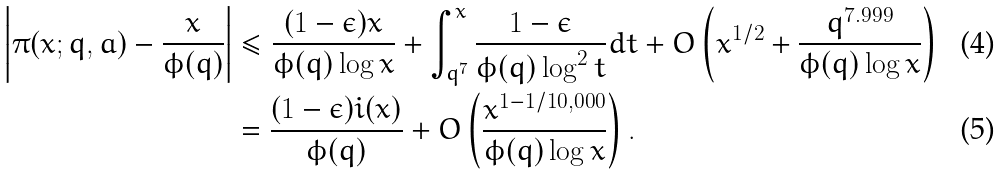<formula> <loc_0><loc_0><loc_500><loc_500>\left | \pi ( x ; q , a ) - \frac { x } { \phi ( q ) } \right | & \leq \frac { ( 1 - \epsilon ) x } { \phi ( q ) \log { x } } + \int _ { q ^ { 7 } } ^ { x } \frac { 1 - \epsilon } { \phi ( q ) \log ^ { 2 } { t } } d t + O \left ( x ^ { 1 / 2 } + \frac { q ^ { 7 . 9 9 9 } } { \phi ( q ) \log { x } } \right ) \\ & = \frac { ( 1 - \epsilon ) \L i ( x ) } { \phi ( q ) } + O \left ( \frac { x ^ { 1 - 1 / 1 0 , 0 0 0 } } { \phi ( q ) \log { x } } \right ) .</formula> 